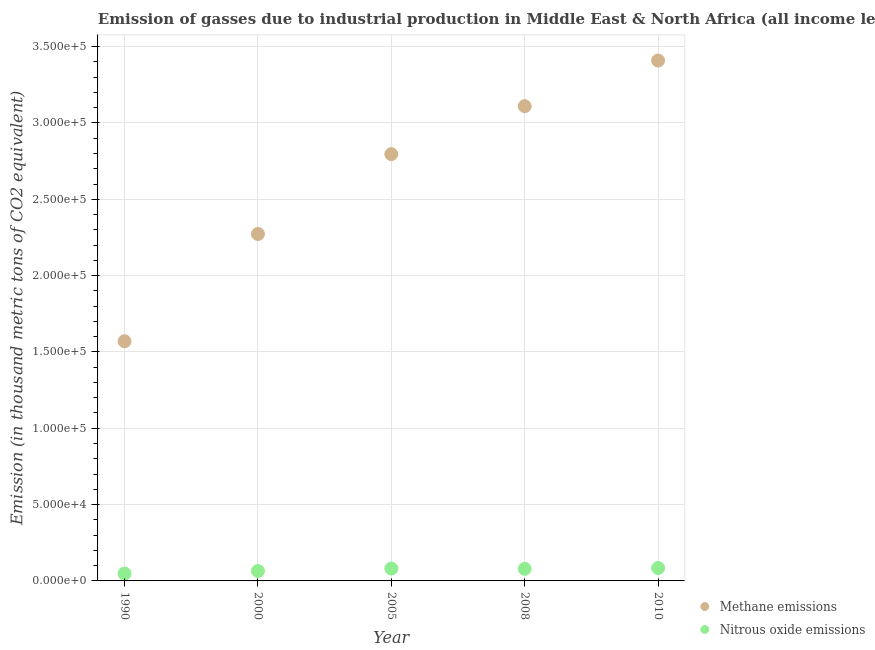What is the amount of nitrous oxide emissions in 2008?
Provide a succinct answer. 7927.7. Across all years, what is the maximum amount of methane emissions?
Your answer should be very brief. 3.41e+05. Across all years, what is the minimum amount of methane emissions?
Make the answer very short. 1.57e+05. In which year was the amount of methane emissions maximum?
Offer a very short reply. 2010. In which year was the amount of nitrous oxide emissions minimum?
Your response must be concise. 1990. What is the total amount of methane emissions in the graph?
Your answer should be very brief. 1.32e+06. What is the difference between the amount of nitrous oxide emissions in 1990 and that in 2008?
Offer a terse response. -3132.5. What is the difference between the amount of methane emissions in 2000 and the amount of nitrous oxide emissions in 2008?
Provide a succinct answer. 2.19e+05. What is the average amount of nitrous oxide emissions per year?
Keep it short and to the point. 7156.2. In the year 2008, what is the difference between the amount of nitrous oxide emissions and amount of methane emissions?
Provide a short and direct response. -3.03e+05. In how many years, is the amount of nitrous oxide emissions greater than 120000 thousand metric tons?
Provide a succinct answer. 0. What is the ratio of the amount of nitrous oxide emissions in 1990 to that in 2008?
Your response must be concise. 0.6. Is the difference between the amount of methane emissions in 2008 and 2010 greater than the difference between the amount of nitrous oxide emissions in 2008 and 2010?
Your response must be concise. No. What is the difference between the highest and the second highest amount of methane emissions?
Your answer should be very brief. 2.99e+04. What is the difference between the highest and the lowest amount of nitrous oxide emissions?
Offer a very short reply. 3647.3. Is the amount of methane emissions strictly greater than the amount of nitrous oxide emissions over the years?
Offer a very short reply. Yes. Is the amount of methane emissions strictly less than the amount of nitrous oxide emissions over the years?
Give a very brief answer. No. How many dotlines are there?
Give a very brief answer. 2. What is the difference between two consecutive major ticks on the Y-axis?
Offer a very short reply. 5.00e+04. Where does the legend appear in the graph?
Keep it short and to the point. Bottom right. How are the legend labels stacked?
Offer a very short reply. Vertical. What is the title of the graph?
Ensure brevity in your answer.  Emission of gasses due to industrial production in Middle East & North Africa (all income levels). What is the label or title of the Y-axis?
Make the answer very short. Emission (in thousand metric tons of CO2 equivalent). What is the Emission (in thousand metric tons of CO2 equivalent) of Methane emissions in 1990?
Your answer should be very brief. 1.57e+05. What is the Emission (in thousand metric tons of CO2 equivalent) of Nitrous oxide emissions in 1990?
Provide a succinct answer. 4795.2. What is the Emission (in thousand metric tons of CO2 equivalent) of Methane emissions in 2000?
Give a very brief answer. 2.27e+05. What is the Emission (in thousand metric tons of CO2 equivalent) of Nitrous oxide emissions in 2000?
Provide a short and direct response. 6497. What is the Emission (in thousand metric tons of CO2 equivalent) in Methane emissions in 2005?
Offer a very short reply. 2.80e+05. What is the Emission (in thousand metric tons of CO2 equivalent) of Nitrous oxide emissions in 2005?
Your answer should be compact. 8118.6. What is the Emission (in thousand metric tons of CO2 equivalent) of Methane emissions in 2008?
Ensure brevity in your answer.  3.11e+05. What is the Emission (in thousand metric tons of CO2 equivalent) in Nitrous oxide emissions in 2008?
Make the answer very short. 7927.7. What is the Emission (in thousand metric tons of CO2 equivalent) in Methane emissions in 2010?
Ensure brevity in your answer.  3.41e+05. What is the Emission (in thousand metric tons of CO2 equivalent) of Nitrous oxide emissions in 2010?
Provide a short and direct response. 8442.5. Across all years, what is the maximum Emission (in thousand metric tons of CO2 equivalent) of Methane emissions?
Provide a short and direct response. 3.41e+05. Across all years, what is the maximum Emission (in thousand metric tons of CO2 equivalent) of Nitrous oxide emissions?
Your response must be concise. 8442.5. Across all years, what is the minimum Emission (in thousand metric tons of CO2 equivalent) of Methane emissions?
Your response must be concise. 1.57e+05. Across all years, what is the minimum Emission (in thousand metric tons of CO2 equivalent) in Nitrous oxide emissions?
Make the answer very short. 4795.2. What is the total Emission (in thousand metric tons of CO2 equivalent) in Methane emissions in the graph?
Offer a terse response. 1.32e+06. What is the total Emission (in thousand metric tons of CO2 equivalent) in Nitrous oxide emissions in the graph?
Keep it short and to the point. 3.58e+04. What is the difference between the Emission (in thousand metric tons of CO2 equivalent) of Methane emissions in 1990 and that in 2000?
Provide a succinct answer. -7.03e+04. What is the difference between the Emission (in thousand metric tons of CO2 equivalent) in Nitrous oxide emissions in 1990 and that in 2000?
Offer a terse response. -1701.8. What is the difference between the Emission (in thousand metric tons of CO2 equivalent) in Methane emissions in 1990 and that in 2005?
Offer a terse response. -1.23e+05. What is the difference between the Emission (in thousand metric tons of CO2 equivalent) of Nitrous oxide emissions in 1990 and that in 2005?
Provide a succinct answer. -3323.4. What is the difference between the Emission (in thousand metric tons of CO2 equivalent) of Methane emissions in 1990 and that in 2008?
Keep it short and to the point. -1.54e+05. What is the difference between the Emission (in thousand metric tons of CO2 equivalent) of Nitrous oxide emissions in 1990 and that in 2008?
Ensure brevity in your answer.  -3132.5. What is the difference between the Emission (in thousand metric tons of CO2 equivalent) of Methane emissions in 1990 and that in 2010?
Provide a succinct answer. -1.84e+05. What is the difference between the Emission (in thousand metric tons of CO2 equivalent) of Nitrous oxide emissions in 1990 and that in 2010?
Ensure brevity in your answer.  -3647.3. What is the difference between the Emission (in thousand metric tons of CO2 equivalent) of Methane emissions in 2000 and that in 2005?
Give a very brief answer. -5.23e+04. What is the difference between the Emission (in thousand metric tons of CO2 equivalent) of Nitrous oxide emissions in 2000 and that in 2005?
Provide a short and direct response. -1621.6. What is the difference between the Emission (in thousand metric tons of CO2 equivalent) in Methane emissions in 2000 and that in 2008?
Your answer should be very brief. -8.37e+04. What is the difference between the Emission (in thousand metric tons of CO2 equivalent) in Nitrous oxide emissions in 2000 and that in 2008?
Provide a succinct answer. -1430.7. What is the difference between the Emission (in thousand metric tons of CO2 equivalent) of Methane emissions in 2000 and that in 2010?
Ensure brevity in your answer.  -1.14e+05. What is the difference between the Emission (in thousand metric tons of CO2 equivalent) of Nitrous oxide emissions in 2000 and that in 2010?
Offer a terse response. -1945.5. What is the difference between the Emission (in thousand metric tons of CO2 equivalent) in Methane emissions in 2005 and that in 2008?
Make the answer very short. -3.14e+04. What is the difference between the Emission (in thousand metric tons of CO2 equivalent) of Nitrous oxide emissions in 2005 and that in 2008?
Offer a terse response. 190.9. What is the difference between the Emission (in thousand metric tons of CO2 equivalent) in Methane emissions in 2005 and that in 2010?
Provide a short and direct response. -6.13e+04. What is the difference between the Emission (in thousand metric tons of CO2 equivalent) of Nitrous oxide emissions in 2005 and that in 2010?
Your answer should be very brief. -323.9. What is the difference between the Emission (in thousand metric tons of CO2 equivalent) in Methane emissions in 2008 and that in 2010?
Provide a succinct answer. -2.99e+04. What is the difference between the Emission (in thousand metric tons of CO2 equivalent) in Nitrous oxide emissions in 2008 and that in 2010?
Your answer should be very brief. -514.8. What is the difference between the Emission (in thousand metric tons of CO2 equivalent) of Methane emissions in 1990 and the Emission (in thousand metric tons of CO2 equivalent) of Nitrous oxide emissions in 2000?
Provide a succinct answer. 1.50e+05. What is the difference between the Emission (in thousand metric tons of CO2 equivalent) of Methane emissions in 1990 and the Emission (in thousand metric tons of CO2 equivalent) of Nitrous oxide emissions in 2005?
Give a very brief answer. 1.49e+05. What is the difference between the Emission (in thousand metric tons of CO2 equivalent) in Methane emissions in 1990 and the Emission (in thousand metric tons of CO2 equivalent) in Nitrous oxide emissions in 2008?
Provide a succinct answer. 1.49e+05. What is the difference between the Emission (in thousand metric tons of CO2 equivalent) in Methane emissions in 1990 and the Emission (in thousand metric tons of CO2 equivalent) in Nitrous oxide emissions in 2010?
Ensure brevity in your answer.  1.49e+05. What is the difference between the Emission (in thousand metric tons of CO2 equivalent) of Methane emissions in 2000 and the Emission (in thousand metric tons of CO2 equivalent) of Nitrous oxide emissions in 2005?
Offer a very short reply. 2.19e+05. What is the difference between the Emission (in thousand metric tons of CO2 equivalent) in Methane emissions in 2000 and the Emission (in thousand metric tons of CO2 equivalent) in Nitrous oxide emissions in 2008?
Make the answer very short. 2.19e+05. What is the difference between the Emission (in thousand metric tons of CO2 equivalent) of Methane emissions in 2000 and the Emission (in thousand metric tons of CO2 equivalent) of Nitrous oxide emissions in 2010?
Provide a succinct answer. 2.19e+05. What is the difference between the Emission (in thousand metric tons of CO2 equivalent) of Methane emissions in 2005 and the Emission (in thousand metric tons of CO2 equivalent) of Nitrous oxide emissions in 2008?
Ensure brevity in your answer.  2.72e+05. What is the difference between the Emission (in thousand metric tons of CO2 equivalent) of Methane emissions in 2005 and the Emission (in thousand metric tons of CO2 equivalent) of Nitrous oxide emissions in 2010?
Provide a succinct answer. 2.71e+05. What is the difference between the Emission (in thousand metric tons of CO2 equivalent) in Methane emissions in 2008 and the Emission (in thousand metric tons of CO2 equivalent) in Nitrous oxide emissions in 2010?
Make the answer very short. 3.03e+05. What is the average Emission (in thousand metric tons of CO2 equivalent) of Methane emissions per year?
Offer a very short reply. 2.63e+05. What is the average Emission (in thousand metric tons of CO2 equivalent) in Nitrous oxide emissions per year?
Your response must be concise. 7156.2. In the year 1990, what is the difference between the Emission (in thousand metric tons of CO2 equivalent) in Methane emissions and Emission (in thousand metric tons of CO2 equivalent) in Nitrous oxide emissions?
Give a very brief answer. 1.52e+05. In the year 2000, what is the difference between the Emission (in thousand metric tons of CO2 equivalent) of Methane emissions and Emission (in thousand metric tons of CO2 equivalent) of Nitrous oxide emissions?
Keep it short and to the point. 2.21e+05. In the year 2005, what is the difference between the Emission (in thousand metric tons of CO2 equivalent) in Methane emissions and Emission (in thousand metric tons of CO2 equivalent) in Nitrous oxide emissions?
Offer a very short reply. 2.71e+05. In the year 2008, what is the difference between the Emission (in thousand metric tons of CO2 equivalent) of Methane emissions and Emission (in thousand metric tons of CO2 equivalent) of Nitrous oxide emissions?
Keep it short and to the point. 3.03e+05. In the year 2010, what is the difference between the Emission (in thousand metric tons of CO2 equivalent) of Methane emissions and Emission (in thousand metric tons of CO2 equivalent) of Nitrous oxide emissions?
Provide a succinct answer. 3.32e+05. What is the ratio of the Emission (in thousand metric tons of CO2 equivalent) in Methane emissions in 1990 to that in 2000?
Your response must be concise. 0.69. What is the ratio of the Emission (in thousand metric tons of CO2 equivalent) of Nitrous oxide emissions in 1990 to that in 2000?
Offer a very short reply. 0.74. What is the ratio of the Emission (in thousand metric tons of CO2 equivalent) of Methane emissions in 1990 to that in 2005?
Ensure brevity in your answer.  0.56. What is the ratio of the Emission (in thousand metric tons of CO2 equivalent) of Nitrous oxide emissions in 1990 to that in 2005?
Offer a very short reply. 0.59. What is the ratio of the Emission (in thousand metric tons of CO2 equivalent) of Methane emissions in 1990 to that in 2008?
Provide a short and direct response. 0.5. What is the ratio of the Emission (in thousand metric tons of CO2 equivalent) in Nitrous oxide emissions in 1990 to that in 2008?
Keep it short and to the point. 0.6. What is the ratio of the Emission (in thousand metric tons of CO2 equivalent) in Methane emissions in 1990 to that in 2010?
Provide a short and direct response. 0.46. What is the ratio of the Emission (in thousand metric tons of CO2 equivalent) of Nitrous oxide emissions in 1990 to that in 2010?
Provide a succinct answer. 0.57. What is the ratio of the Emission (in thousand metric tons of CO2 equivalent) of Methane emissions in 2000 to that in 2005?
Provide a short and direct response. 0.81. What is the ratio of the Emission (in thousand metric tons of CO2 equivalent) of Nitrous oxide emissions in 2000 to that in 2005?
Give a very brief answer. 0.8. What is the ratio of the Emission (in thousand metric tons of CO2 equivalent) in Methane emissions in 2000 to that in 2008?
Provide a succinct answer. 0.73. What is the ratio of the Emission (in thousand metric tons of CO2 equivalent) of Nitrous oxide emissions in 2000 to that in 2008?
Your answer should be very brief. 0.82. What is the ratio of the Emission (in thousand metric tons of CO2 equivalent) of Methane emissions in 2000 to that in 2010?
Provide a short and direct response. 0.67. What is the ratio of the Emission (in thousand metric tons of CO2 equivalent) of Nitrous oxide emissions in 2000 to that in 2010?
Make the answer very short. 0.77. What is the ratio of the Emission (in thousand metric tons of CO2 equivalent) of Methane emissions in 2005 to that in 2008?
Your answer should be compact. 0.9. What is the ratio of the Emission (in thousand metric tons of CO2 equivalent) of Nitrous oxide emissions in 2005 to that in 2008?
Ensure brevity in your answer.  1.02. What is the ratio of the Emission (in thousand metric tons of CO2 equivalent) in Methane emissions in 2005 to that in 2010?
Make the answer very short. 0.82. What is the ratio of the Emission (in thousand metric tons of CO2 equivalent) in Nitrous oxide emissions in 2005 to that in 2010?
Your answer should be compact. 0.96. What is the ratio of the Emission (in thousand metric tons of CO2 equivalent) of Methane emissions in 2008 to that in 2010?
Keep it short and to the point. 0.91. What is the ratio of the Emission (in thousand metric tons of CO2 equivalent) in Nitrous oxide emissions in 2008 to that in 2010?
Your answer should be very brief. 0.94. What is the difference between the highest and the second highest Emission (in thousand metric tons of CO2 equivalent) of Methane emissions?
Offer a very short reply. 2.99e+04. What is the difference between the highest and the second highest Emission (in thousand metric tons of CO2 equivalent) in Nitrous oxide emissions?
Give a very brief answer. 323.9. What is the difference between the highest and the lowest Emission (in thousand metric tons of CO2 equivalent) in Methane emissions?
Give a very brief answer. 1.84e+05. What is the difference between the highest and the lowest Emission (in thousand metric tons of CO2 equivalent) of Nitrous oxide emissions?
Give a very brief answer. 3647.3. 